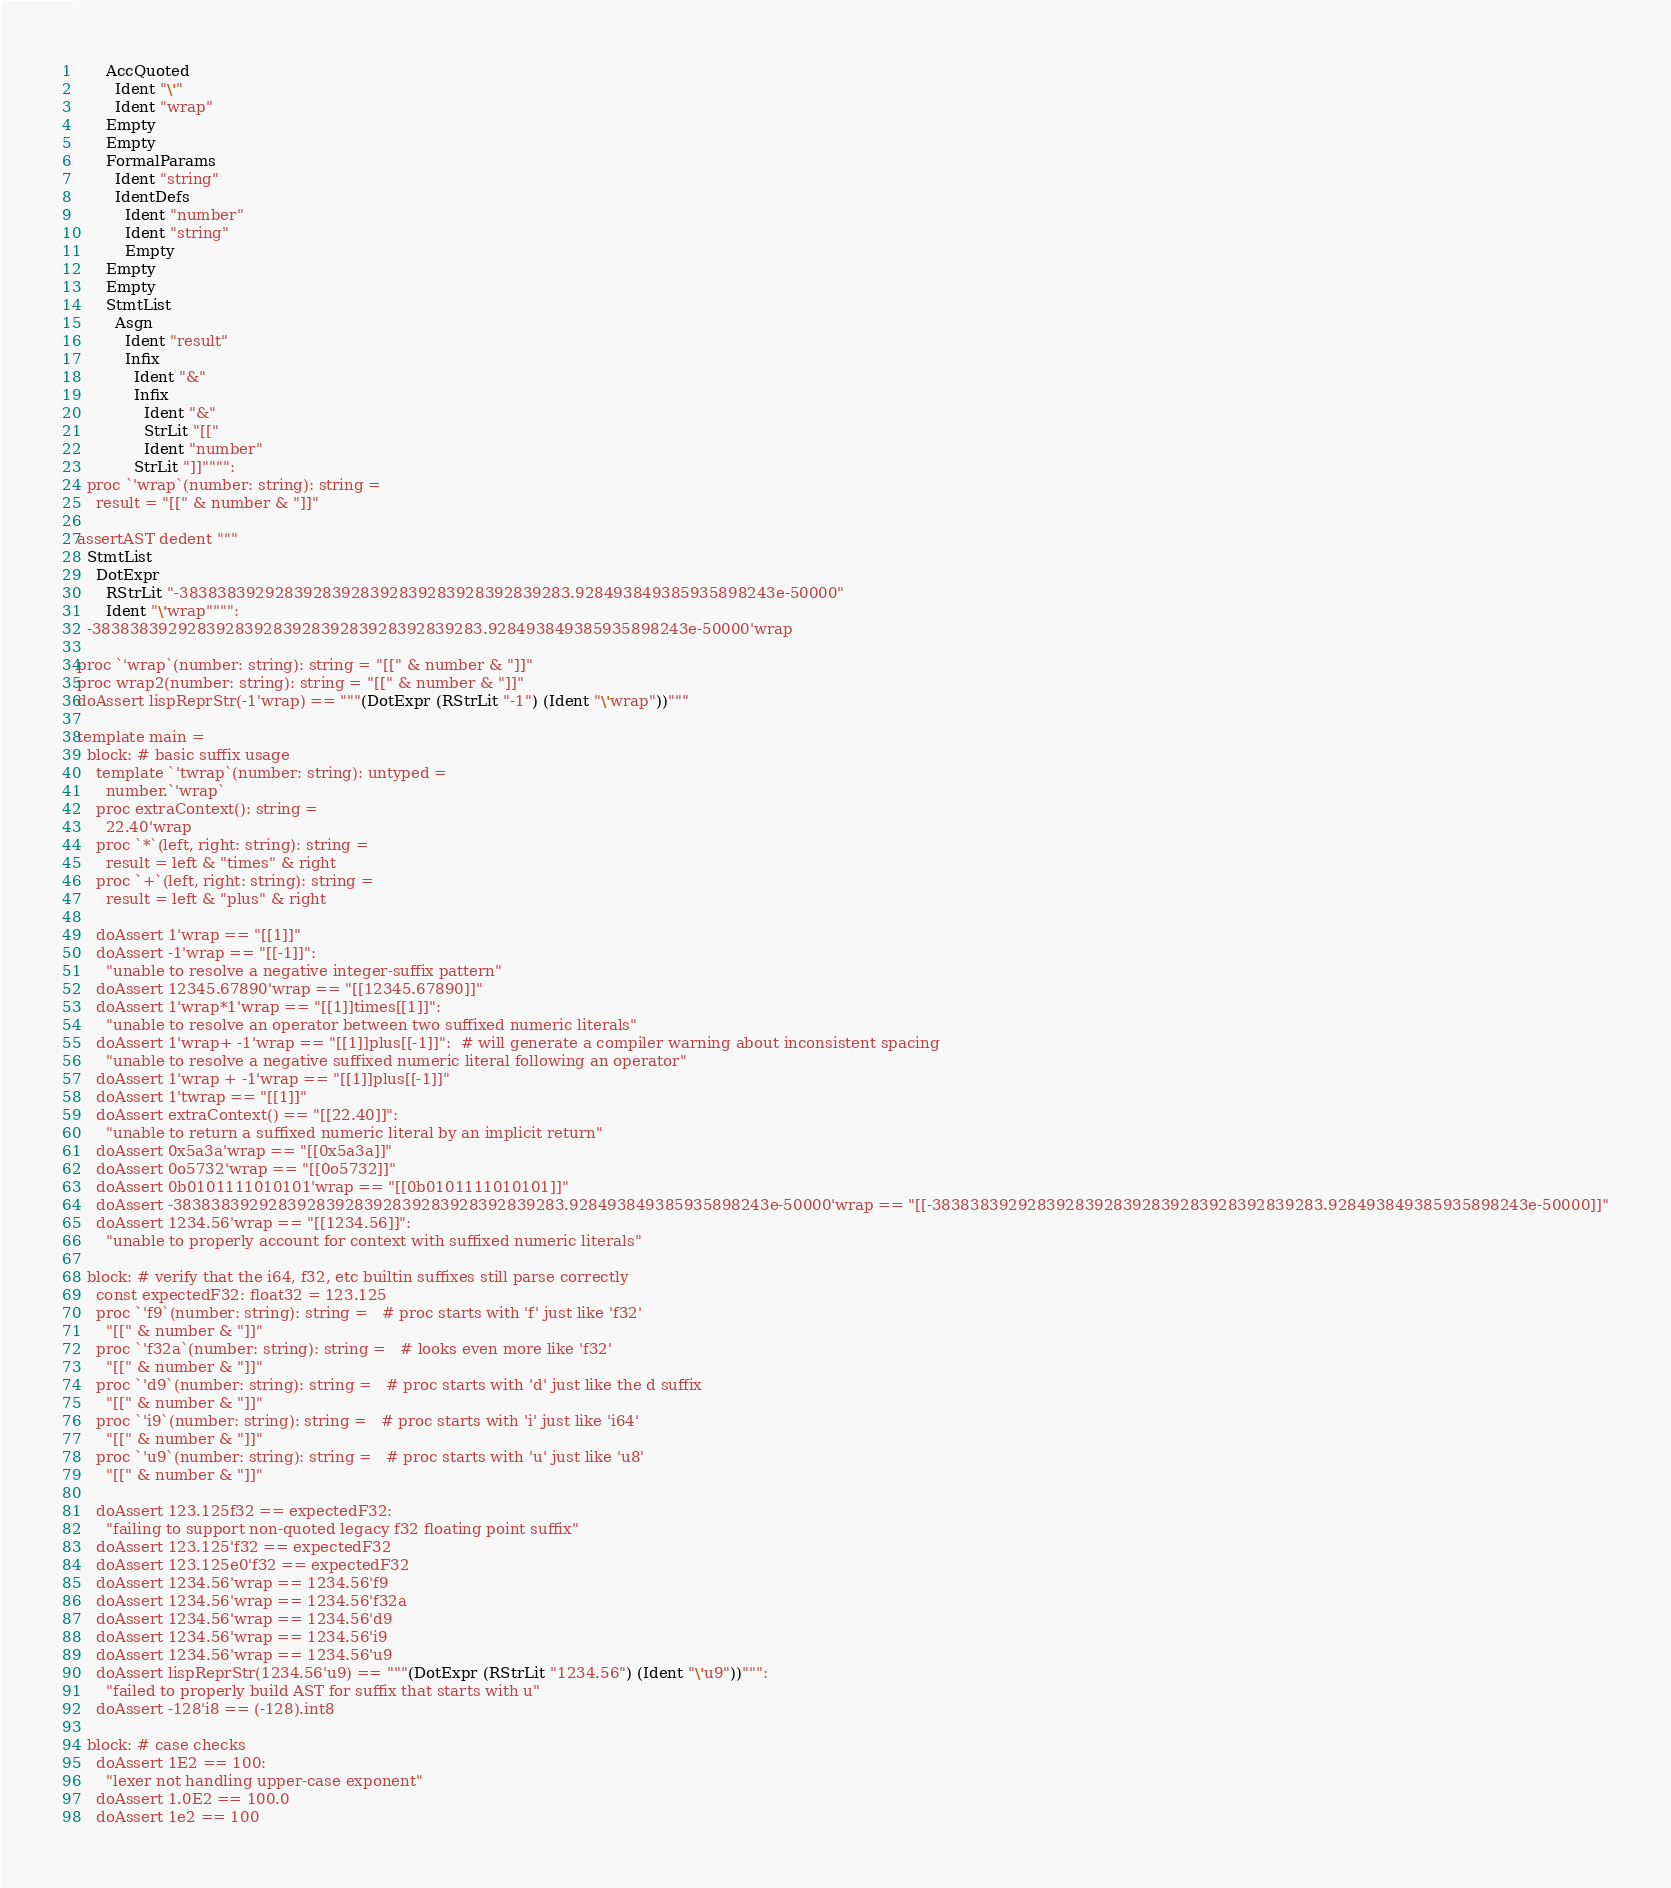Convert code to text. <code><loc_0><loc_0><loc_500><loc_500><_Nim_>      AccQuoted
        Ident "\'"
        Ident "wrap"
      Empty
      Empty
      FormalParams
        Ident "string"
        IdentDefs
          Ident "number"
          Ident "string"
          Empty
      Empty
      Empty
      StmtList
        Asgn
          Ident "result"
          Infix
            Ident "&"
            Infix
              Ident "&"
              StrLit "[["
              Ident "number"
            StrLit "]]"""":
  proc `'wrap`(number: string): string =
    result = "[[" & number & "]]"

assertAST dedent """
  StmtList
    DotExpr
      RStrLit "-38383839292839283928392839283928392839283.928493849385935898243e-50000"
      Ident "\'wrap"""":
  -38383839292839283928392839283928392839283.928493849385935898243e-50000'wrap

proc `'wrap`(number: string): string = "[[" & number & "]]"
proc wrap2(number: string): string = "[[" & number & "]]"
doAssert lispReprStr(-1'wrap) == """(DotExpr (RStrLit "-1") (Ident "\'wrap"))"""

template main =
  block: # basic suffix usage
    template `'twrap`(number: string): untyped =
      number.`'wrap`
    proc extraContext(): string =
      22.40'wrap
    proc `*`(left, right: string): string =
      result = left & "times" & right
    proc `+`(left, right: string): string =
      result = left & "plus" & right

    doAssert 1'wrap == "[[1]]"
    doAssert -1'wrap == "[[-1]]":
      "unable to resolve a negative integer-suffix pattern"
    doAssert 12345.67890'wrap == "[[12345.67890]]"
    doAssert 1'wrap*1'wrap == "[[1]]times[[1]]":
      "unable to resolve an operator between two suffixed numeric literals"
    doAssert 1'wrap+ -1'wrap == "[[1]]plus[[-1]]":  # will generate a compiler warning about inconsistent spacing
      "unable to resolve a negative suffixed numeric literal following an operator"
    doAssert 1'wrap + -1'wrap == "[[1]]plus[[-1]]"
    doAssert 1'twrap == "[[1]]"
    doAssert extraContext() == "[[22.40]]":
      "unable to return a suffixed numeric literal by an implicit return"
    doAssert 0x5a3a'wrap == "[[0x5a3a]]"
    doAssert 0o5732'wrap == "[[0o5732]]"
    doAssert 0b0101111010101'wrap == "[[0b0101111010101]]"
    doAssert -38383839292839283928392839283928392839283.928493849385935898243e-50000'wrap == "[[-38383839292839283928392839283928392839283.928493849385935898243e-50000]]"
    doAssert 1234.56'wrap == "[[1234.56]]":
      "unable to properly account for context with suffixed numeric literals"

  block: # verify that the i64, f32, etc builtin suffixes still parse correctly
    const expectedF32: float32 = 123.125
    proc `'f9`(number: string): string =   # proc starts with 'f' just like 'f32'
      "[[" & number & "]]"
    proc `'f32a`(number: string): string =   # looks even more like 'f32'
      "[[" & number & "]]"
    proc `'d9`(number: string): string =   # proc starts with 'd' just like the d suffix
      "[[" & number & "]]"
    proc `'i9`(number: string): string =   # proc starts with 'i' just like 'i64'
      "[[" & number & "]]"
    proc `'u9`(number: string): string =   # proc starts with 'u' just like 'u8'
      "[[" & number & "]]"

    doAssert 123.125f32 == expectedF32:
      "failing to support non-quoted legacy f32 floating point suffix"
    doAssert 123.125'f32 == expectedF32
    doAssert 123.125e0'f32 == expectedF32
    doAssert 1234.56'wrap == 1234.56'f9
    doAssert 1234.56'wrap == 1234.56'f32a
    doAssert 1234.56'wrap == 1234.56'd9
    doAssert 1234.56'wrap == 1234.56'i9
    doAssert 1234.56'wrap == 1234.56'u9
    doAssert lispReprStr(1234.56'u9) == """(DotExpr (RStrLit "1234.56") (Ident "\'u9"))""":
      "failed to properly build AST for suffix that starts with u"
    doAssert -128'i8 == (-128).int8

  block: # case checks
    doAssert 1E2 == 100:
      "lexer not handling upper-case exponent"
    doAssert 1.0E2 == 100.0
    doAssert 1e2 == 100</code> 